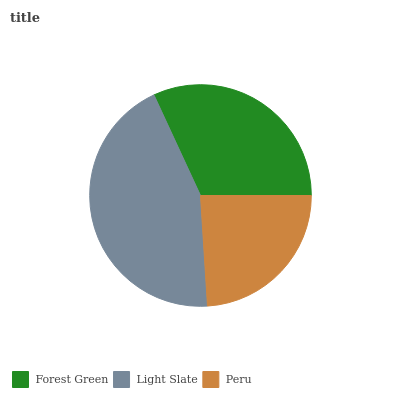Is Peru the minimum?
Answer yes or no. Yes. Is Light Slate the maximum?
Answer yes or no. Yes. Is Light Slate the minimum?
Answer yes or no. No. Is Peru the maximum?
Answer yes or no. No. Is Light Slate greater than Peru?
Answer yes or no. Yes. Is Peru less than Light Slate?
Answer yes or no. Yes. Is Peru greater than Light Slate?
Answer yes or no. No. Is Light Slate less than Peru?
Answer yes or no. No. Is Forest Green the high median?
Answer yes or no. Yes. Is Forest Green the low median?
Answer yes or no. Yes. Is Peru the high median?
Answer yes or no. No. Is Peru the low median?
Answer yes or no. No. 